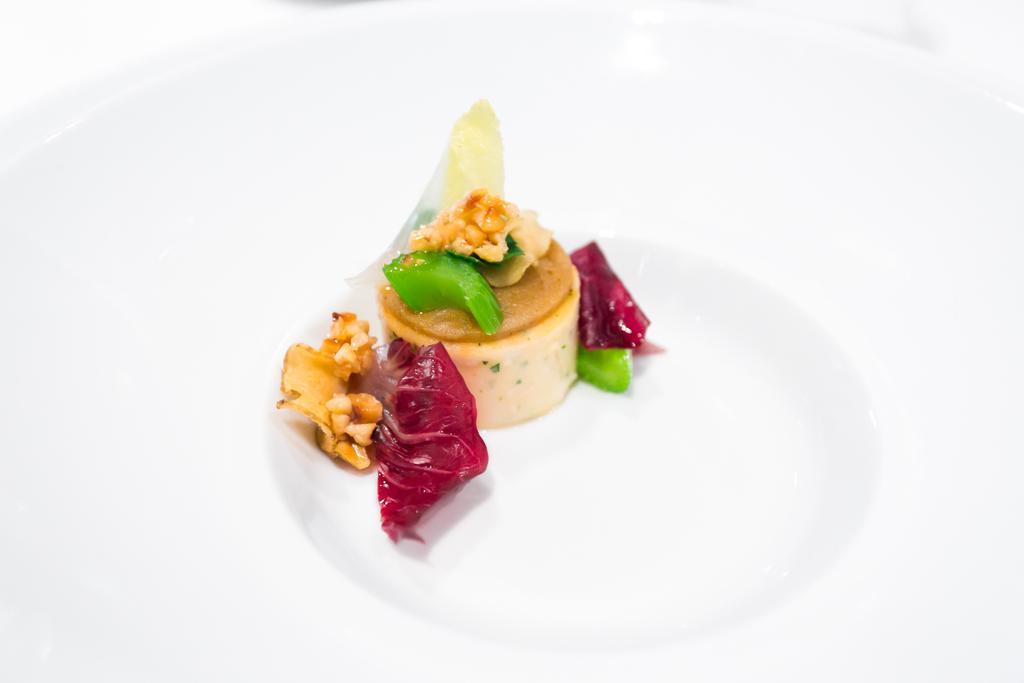Could you give a brief overview of what you see in this image? In this image we can see food on a plate placed on the surface. 